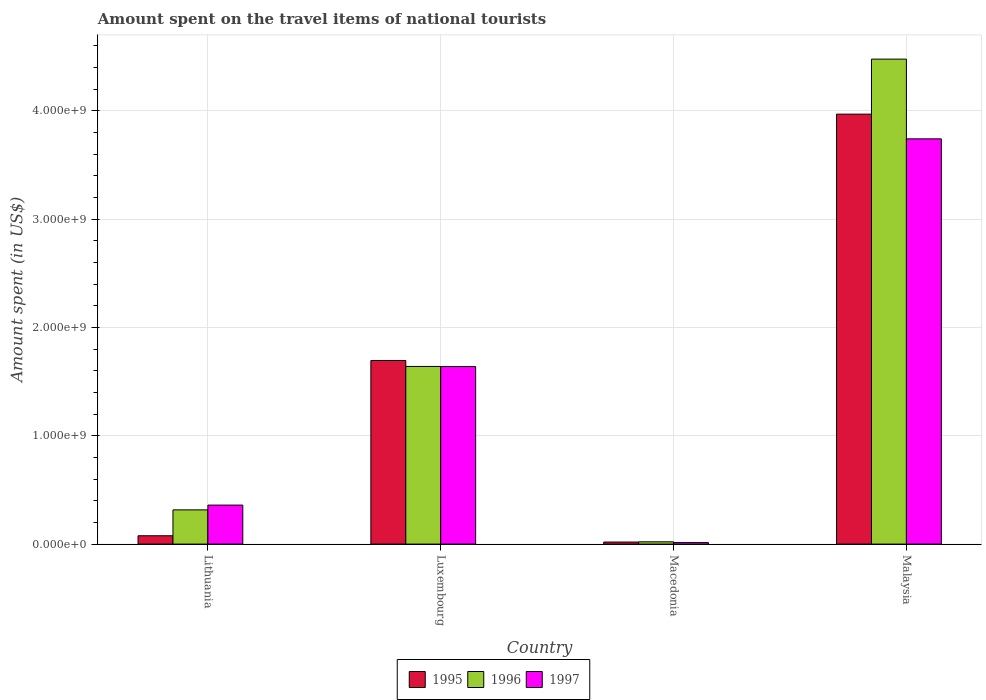How many groups of bars are there?
Keep it short and to the point. 4. Are the number of bars per tick equal to the number of legend labels?
Make the answer very short. Yes. Are the number of bars on each tick of the X-axis equal?
Offer a very short reply. Yes. How many bars are there on the 2nd tick from the right?
Keep it short and to the point. 3. What is the label of the 3rd group of bars from the left?
Your answer should be very brief. Macedonia. In how many cases, is the number of bars for a given country not equal to the number of legend labels?
Provide a succinct answer. 0. What is the amount spent on the travel items of national tourists in 1997 in Lithuania?
Offer a very short reply. 3.60e+08. Across all countries, what is the maximum amount spent on the travel items of national tourists in 1997?
Give a very brief answer. 3.74e+09. Across all countries, what is the minimum amount spent on the travel items of national tourists in 1996?
Provide a succinct answer. 2.10e+07. In which country was the amount spent on the travel items of national tourists in 1996 maximum?
Ensure brevity in your answer.  Malaysia. In which country was the amount spent on the travel items of national tourists in 1996 minimum?
Give a very brief answer. Macedonia. What is the total amount spent on the travel items of national tourists in 1996 in the graph?
Provide a succinct answer. 6.45e+09. What is the difference between the amount spent on the travel items of national tourists in 1995 in Luxembourg and that in Malaysia?
Keep it short and to the point. -2.27e+09. What is the difference between the amount spent on the travel items of national tourists in 1996 in Luxembourg and the amount spent on the travel items of national tourists in 1997 in Lithuania?
Offer a very short reply. 1.28e+09. What is the average amount spent on the travel items of national tourists in 1996 per country?
Give a very brief answer. 1.61e+09. What is the difference between the amount spent on the travel items of national tourists of/in 1995 and amount spent on the travel items of national tourists of/in 1997 in Luxembourg?
Offer a very short reply. 5.60e+07. In how many countries, is the amount spent on the travel items of national tourists in 1995 greater than 4000000000 US$?
Ensure brevity in your answer.  0. What is the ratio of the amount spent on the travel items of national tourists in 1997 in Lithuania to that in Malaysia?
Provide a succinct answer. 0.1. Is the difference between the amount spent on the travel items of national tourists in 1995 in Lithuania and Macedonia greater than the difference between the amount spent on the travel items of national tourists in 1997 in Lithuania and Macedonia?
Your answer should be very brief. No. What is the difference between the highest and the second highest amount spent on the travel items of national tourists in 1997?
Provide a short and direct response. 3.38e+09. What is the difference between the highest and the lowest amount spent on the travel items of national tourists in 1997?
Offer a very short reply. 3.73e+09. In how many countries, is the amount spent on the travel items of national tourists in 1995 greater than the average amount spent on the travel items of national tourists in 1995 taken over all countries?
Your response must be concise. 2. Is the sum of the amount spent on the travel items of national tourists in 1996 in Luxembourg and Macedonia greater than the maximum amount spent on the travel items of national tourists in 1997 across all countries?
Provide a short and direct response. No. Is it the case that in every country, the sum of the amount spent on the travel items of national tourists in 1996 and amount spent on the travel items of national tourists in 1997 is greater than the amount spent on the travel items of national tourists in 1995?
Ensure brevity in your answer.  Yes. How many countries are there in the graph?
Keep it short and to the point. 4. What is the difference between two consecutive major ticks on the Y-axis?
Your answer should be compact. 1.00e+09. Does the graph contain any zero values?
Provide a succinct answer. No. How many legend labels are there?
Offer a terse response. 3. What is the title of the graph?
Keep it short and to the point. Amount spent on the travel items of national tourists. What is the label or title of the X-axis?
Offer a very short reply. Country. What is the label or title of the Y-axis?
Make the answer very short. Amount spent (in US$). What is the Amount spent (in US$) of 1995 in Lithuania?
Your answer should be very brief. 7.70e+07. What is the Amount spent (in US$) of 1996 in Lithuania?
Make the answer very short. 3.16e+08. What is the Amount spent (in US$) in 1997 in Lithuania?
Provide a succinct answer. 3.60e+08. What is the Amount spent (in US$) of 1995 in Luxembourg?
Your answer should be compact. 1.70e+09. What is the Amount spent (in US$) of 1996 in Luxembourg?
Your answer should be very brief. 1.64e+09. What is the Amount spent (in US$) in 1997 in Luxembourg?
Your answer should be compact. 1.64e+09. What is the Amount spent (in US$) in 1995 in Macedonia?
Keep it short and to the point. 1.90e+07. What is the Amount spent (in US$) in 1996 in Macedonia?
Provide a succinct answer. 2.10e+07. What is the Amount spent (in US$) in 1997 in Macedonia?
Your answer should be compact. 1.40e+07. What is the Amount spent (in US$) in 1995 in Malaysia?
Ensure brevity in your answer.  3.97e+09. What is the Amount spent (in US$) of 1996 in Malaysia?
Provide a succinct answer. 4.48e+09. What is the Amount spent (in US$) of 1997 in Malaysia?
Offer a terse response. 3.74e+09. Across all countries, what is the maximum Amount spent (in US$) in 1995?
Keep it short and to the point. 3.97e+09. Across all countries, what is the maximum Amount spent (in US$) of 1996?
Your answer should be compact. 4.48e+09. Across all countries, what is the maximum Amount spent (in US$) of 1997?
Offer a terse response. 3.74e+09. Across all countries, what is the minimum Amount spent (in US$) of 1995?
Make the answer very short. 1.90e+07. Across all countries, what is the minimum Amount spent (in US$) in 1996?
Your answer should be very brief. 2.10e+07. Across all countries, what is the minimum Amount spent (in US$) of 1997?
Make the answer very short. 1.40e+07. What is the total Amount spent (in US$) in 1995 in the graph?
Provide a short and direct response. 5.76e+09. What is the total Amount spent (in US$) of 1996 in the graph?
Your answer should be very brief. 6.45e+09. What is the total Amount spent (in US$) of 1997 in the graph?
Make the answer very short. 5.75e+09. What is the difference between the Amount spent (in US$) of 1995 in Lithuania and that in Luxembourg?
Give a very brief answer. -1.62e+09. What is the difference between the Amount spent (in US$) of 1996 in Lithuania and that in Luxembourg?
Offer a terse response. -1.32e+09. What is the difference between the Amount spent (in US$) in 1997 in Lithuania and that in Luxembourg?
Offer a very short reply. -1.28e+09. What is the difference between the Amount spent (in US$) in 1995 in Lithuania and that in Macedonia?
Provide a short and direct response. 5.80e+07. What is the difference between the Amount spent (in US$) in 1996 in Lithuania and that in Macedonia?
Your response must be concise. 2.95e+08. What is the difference between the Amount spent (in US$) of 1997 in Lithuania and that in Macedonia?
Provide a succinct answer. 3.46e+08. What is the difference between the Amount spent (in US$) in 1995 in Lithuania and that in Malaysia?
Give a very brief answer. -3.89e+09. What is the difference between the Amount spent (in US$) of 1996 in Lithuania and that in Malaysia?
Keep it short and to the point. -4.16e+09. What is the difference between the Amount spent (in US$) of 1997 in Lithuania and that in Malaysia?
Provide a succinct answer. -3.38e+09. What is the difference between the Amount spent (in US$) of 1995 in Luxembourg and that in Macedonia?
Provide a succinct answer. 1.68e+09. What is the difference between the Amount spent (in US$) of 1996 in Luxembourg and that in Macedonia?
Your response must be concise. 1.62e+09. What is the difference between the Amount spent (in US$) of 1997 in Luxembourg and that in Macedonia?
Your answer should be compact. 1.62e+09. What is the difference between the Amount spent (in US$) in 1995 in Luxembourg and that in Malaysia?
Your answer should be compact. -2.27e+09. What is the difference between the Amount spent (in US$) in 1996 in Luxembourg and that in Malaysia?
Your response must be concise. -2.84e+09. What is the difference between the Amount spent (in US$) of 1997 in Luxembourg and that in Malaysia?
Give a very brief answer. -2.10e+09. What is the difference between the Amount spent (in US$) of 1995 in Macedonia and that in Malaysia?
Offer a very short reply. -3.95e+09. What is the difference between the Amount spent (in US$) in 1996 in Macedonia and that in Malaysia?
Your answer should be very brief. -4.46e+09. What is the difference between the Amount spent (in US$) in 1997 in Macedonia and that in Malaysia?
Provide a succinct answer. -3.73e+09. What is the difference between the Amount spent (in US$) in 1995 in Lithuania and the Amount spent (in US$) in 1996 in Luxembourg?
Your answer should be very brief. -1.56e+09. What is the difference between the Amount spent (in US$) in 1995 in Lithuania and the Amount spent (in US$) in 1997 in Luxembourg?
Your response must be concise. -1.56e+09. What is the difference between the Amount spent (in US$) of 1996 in Lithuania and the Amount spent (in US$) of 1997 in Luxembourg?
Your response must be concise. -1.32e+09. What is the difference between the Amount spent (in US$) of 1995 in Lithuania and the Amount spent (in US$) of 1996 in Macedonia?
Make the answer very short. 5.60e+07. What is the difference between the Amount spent (in US$) of 1995 in Lithuania and the Amount spent (in US$) of 1997 in Macedonia?
Ensure brevity in your answer.  6.30e+07. What is the difference between the Amount spent (in US$) in 1996 in Lithuania and the Amount spent (in US$) in 1997 in Macedonia?
Give a very brief answer. 3.02e+08. What is the difference between the Amount spent (in US$) of 1995 in Lithuania and the Amount spent (in US$) of 1996 in Malaysia?
Your response must be concise. -4.40e+09. What is the difference between the Amount spent (in US$) in 1995 in Lithuania and the Amount spent (in US$) in 1997 in Malaysia?
Ensure brevity in your answer.  -3.66e+09. What is the difference between the Amount spent (in US$) of 1996 in Lithuania and the Amount spent (in US$) of 1997 in Malaysia?
Keep it short and to the point. -3.42e+09. What is the difference between the Amount spent (in US$) of 1995 in Luxembourg and the Amount spent (in US$) of 1996 in Macedonia?
Keep it short and to the point. 1.67e+09. What is the difference between the Amount spent (in US$) of 1995 in Luxembourg and the Amount spent (in US$) of 1997 in Macedonia?
Your answer should be compact. 1.68e+09. What is the difference between the Amount spent (in US$) of 1996 in Luxembourg and the Amount spent (in US$) of 1997 in Macedonia?
Give a very brief answer. 1.63e+09. What is the difference between the Amount spent (in US$) of 1995 in Luxembourg and the Amount spent (in US$) of 1996 in Malaysia?
Provide a succinct answer. -2.78e+09. What is the difference between the Amount spent (in US$) in 1995 in Luxembourg and the Amount spent (in US$) in 1997 in Malaysia?
Provide a short and direct response. -2.05e+09. What is the difference between the Amount spent (in US$) in 1996 in Luxembourg and the Amount spent (in US$) in 1997 in Malaysia?
Provide a succinct answer. -2.10e+09. What is the difference between the Amount spent (in US$) in 1995 in Macedonia and the Amount spent (in US$) in 1996 in Malaysia?
Give a very brief answer. -4.46e+09. What is the difference between the Amount spent (in US$) in 1995 in Macedonia and the Amount spent (in US$) in 1997 in Malaysia?
Ensure brevity in your answer.  -3.72e+09. What is the difference between the Amount spent (in US$) of 1996 in Macedonia and the Amount spent (in US$) of 1997 in Malaysia?
Offer a very short reply. -3.72e+09. What is the average Amount spent (in US$) of 1995 per country?
Your answer should be compact. 1.44e+09. What is the average Amount spent (in US$) in 1996 per country?
Your answer should be very brief. 1.61e+09. What is the average Amount spent (in US$) of 1997 per country?
Your answer should be very brief. 1.44e+09. What is the difference between the Amount spent (in US$) in 1995 and Amount spent (in US$) in 1996 in Lithuania?
Your answer should be very brief. -2.39e+08. What is the difference between the Amount spent (in US$) of 1995 and Amount spent (in US$) of 1997 in Lithuania?
Your answer should be very brief. -2.83e+08. What is the difference between the Amount spent (in US$) in 1996 and Amount spent (in US$) in 1997 in Lithuania?
Keep it short and to the point. -4.40e+07. What is the difference between the Amount spent (in US$) of 1995 and Amount spent (in US$) of 1996 in Luxembourg?
Your answer should be compact. 5.50e+07. What is the difference between the Amount spent (in US$) of 1995 and Amount spent (in US$) of 1997 in Luxembourg?
Offer a very short reply. 5.60e+07. What is the difference between the Amount spent (in US$) in 1996 and Amount spent (in US$) in 1997 in Luxembourg?
Make the answer very short. 1.00e+06. What is the difference between the Amount spent (in US$) of 1996 and Amount spent (in US$) of 1997 in Macedonia?
Your answer should be very brief. 7.00e+06. What is the difference between the Amount spent (in US$) in 1995 and Amount spent (in US$) in 1996 in Malaysia?
Give a very brief answer. -5.08e+08. What is the difference between the Amount spent (in US$) of 1995 and Amount spent (in US$) of 1997 in Malaysia?
Offer a very short reply. 2.28e+08. What is the difference between the Amount spent (in US$) of 1996 and Amount spent (in US$) of 1997 in Malaysia?
Provide a succinct answer. 7.36e+08. What is the ratio of the Amount spent (in US$) of 1995 in Lithuania to that in Luxembourg?
Offer a very short reply. 0.05. What is the ratio of the Amount spent (in US$) in 1996 in Lithuania to that in Luxembourg?
Your answer should be compact. 0.19. What is the ratio of the Amount spent (in US$) of 1997 in Lithuania to that in Luxembourg?
Make the answer very short. 0.22. What is the ratio of the Amount spent (in US$) of 1995 in Lithuania to that in Macedonia?
Offer a terse response. 4.05. What is the ratio of the Amount spent (in US$) of 1996 in Lithuania to that in Macedonia?
Offer a terse response. 15.05. What is the ratio of the Amount spent (in US$) of 1997 in Lithuania to that in Macedonia?
Provide a succinct answer. 25.71. What is the ratio of the Amount spent (in US$) in 1995 in Lithuania to that in Malaysia?
Provide a succinct answer. 0.02. What is the ratio of the Amount spent (in US$) of 1996 in Lithuania to that in Malaysia?
Your answer should be compact. 0.07. What is the ratio of the Amount spent (in US$) in 1997 in Lithuania to that in Malaysia?
Make the answer very short. 0.1. What is the ratio of the Amount spent (in US$) of 1995 in Luxembourg to that in Macedonia?
Offer a very short reply. 89.21. What is the ratio of the Amount spent (in US$) of 1996 in Luxembourg to that in Macedonia?
Your answer should be very brief. 78.1. What is the ratio of the Amount spent (in US$) of 1997 in Luxembourg to that in Macedonia?
Ensure brevity in your answer.  117.07. What is the ratio of the Amount spent (in US$) in 1995 in Luxembourg to that in Malaysia?
Keep it short and to the point. 0.43. What is the ratio of the Amount spent (in US$) of 1996 in Luxembourg to that in Malaysia?
Keep it short and to the point. 0.37. What is the ratio of the Amount spent (in US$) in 1997 in Luxembourg to that in Malaysia?
Keep it short and to the point. 0.44. What is the ratio of the Amount spent (in US$) in 1995 in Macedonia to that in Malaysia?
Give a very brief answer. 0. What is the ratio of the Amount spent (in US$) of 1996 in Macedonia to that in Malaysia?
Provide a short and direct response. 0. What is the ratio of the Amount spent (in US$) in 1997 in Macedonia to that in Malaysia?
Your answer should be very brief. 0. What is the difference between the highest and the second highest Amount spent (in US$) in 1995?
Your answer should be very brief. 2.27e+09. What is the difference between the highest and the second highest Amount spent (in US$) in 1996?
Give a very brief answer. 2.84e+09. What is the difference between the highest and the second highest Amount spent (in US$) of 1997?
Offer a very short reply. 2.10e+09. What is the difference between the highest and the lowest Amount spent (in US$) in 1995?
Provide a succinct answer. 3.95e+09. What is the difference between the highest and the lowest Amount spent (in US$) of 1996?
Ensure brevity in your answer.  4.46e+09. What is the difference between the highest and the lowest Amount spent (in US$) in 1997?
Offer a terse response. 3.73e+09. 